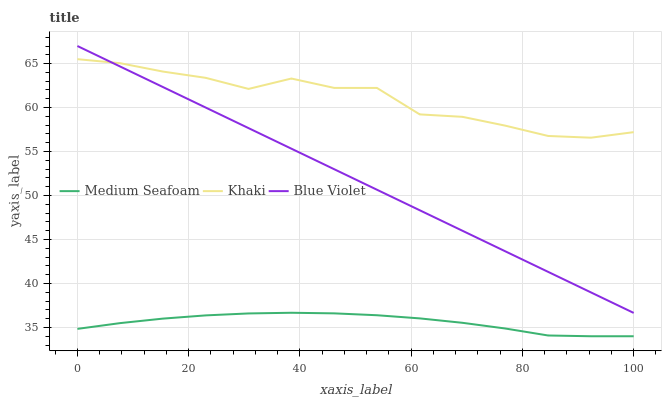Does Medium Seafoam have the minimum area under the curve?
Answer yes or no. Yes. Does Khaki have the maximum area under the curve?
Answer yes or no. Yes. Does Blue Violet have the minimum area under the curve?
Answer yes or no. No. Does Blue Violet have the maximum area under the curve?
Answer yes or no. No. Is Blue Violet the smoothest?
Answer yes or no. Yes. Is Khaki the roughest?
Answer yes or no. Yes. Is Medium Seafoam the smoothest?
Answer yes or no. No. Is Medium Seafoam the roughest?
Answer yes or no. No. Does Medium Seafoam have the lowest value?
Answer yes or no. Yes. Does Blue Violet have the lowest value?
Answer yes or no. No. Does Blue Violet have the highest value?
Answer yes or no. Yes. Does Medium Seafoam have the highest value?
Answer yes or no. No. Is Medium Seafoam less than Blue Violet?
Answer yes or no. Yes. Is Blue Violet greater than Medium Seafoam?
Answer yes or no. Yes. Does Khaki intersect Blue Violet?
Answer yes or no. Yes. Is Khaki less than Blue Violet?
Answer yes or no. No. Is Khaki greater than Blue Violet?
Answer yes or no. No. Does Medium Seafoam intersect Blue Violet?
Answer yes or no. No. 